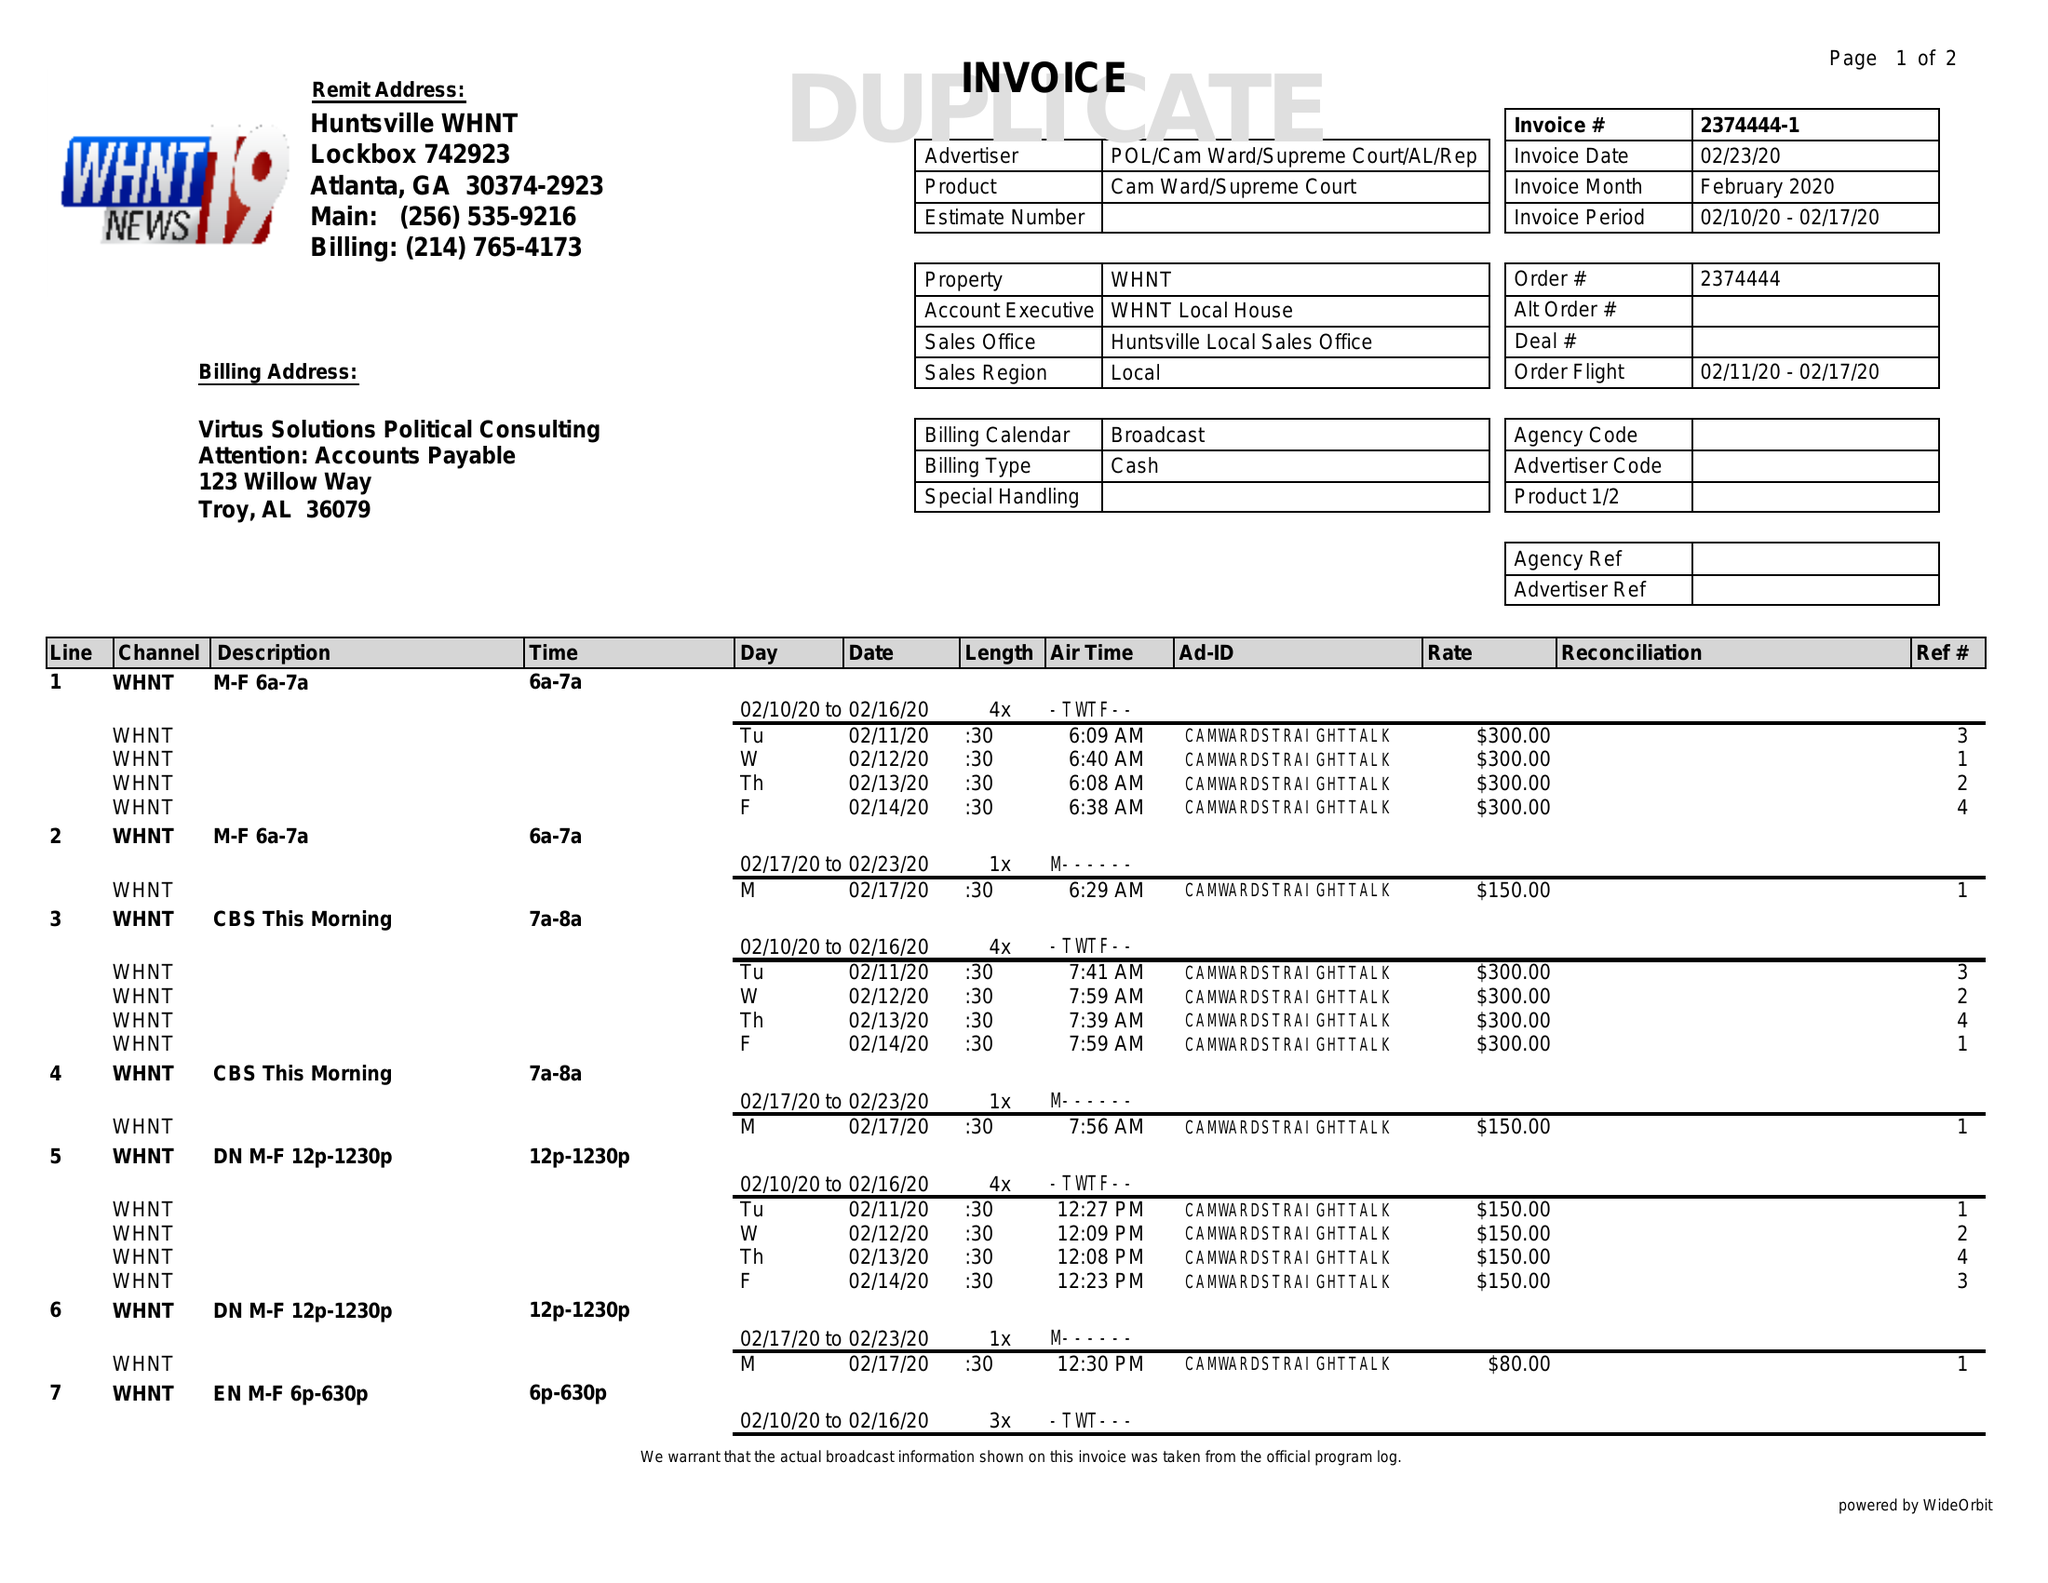What is the value for the advertiser?
Answer the question using a single word or phrase. POL/CAMWARD/SUPREMECOURT/AL/REP 